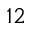<formula> <loc_0><loc_0><loc_500><loc_500>^ { 1 2 }</formula> 